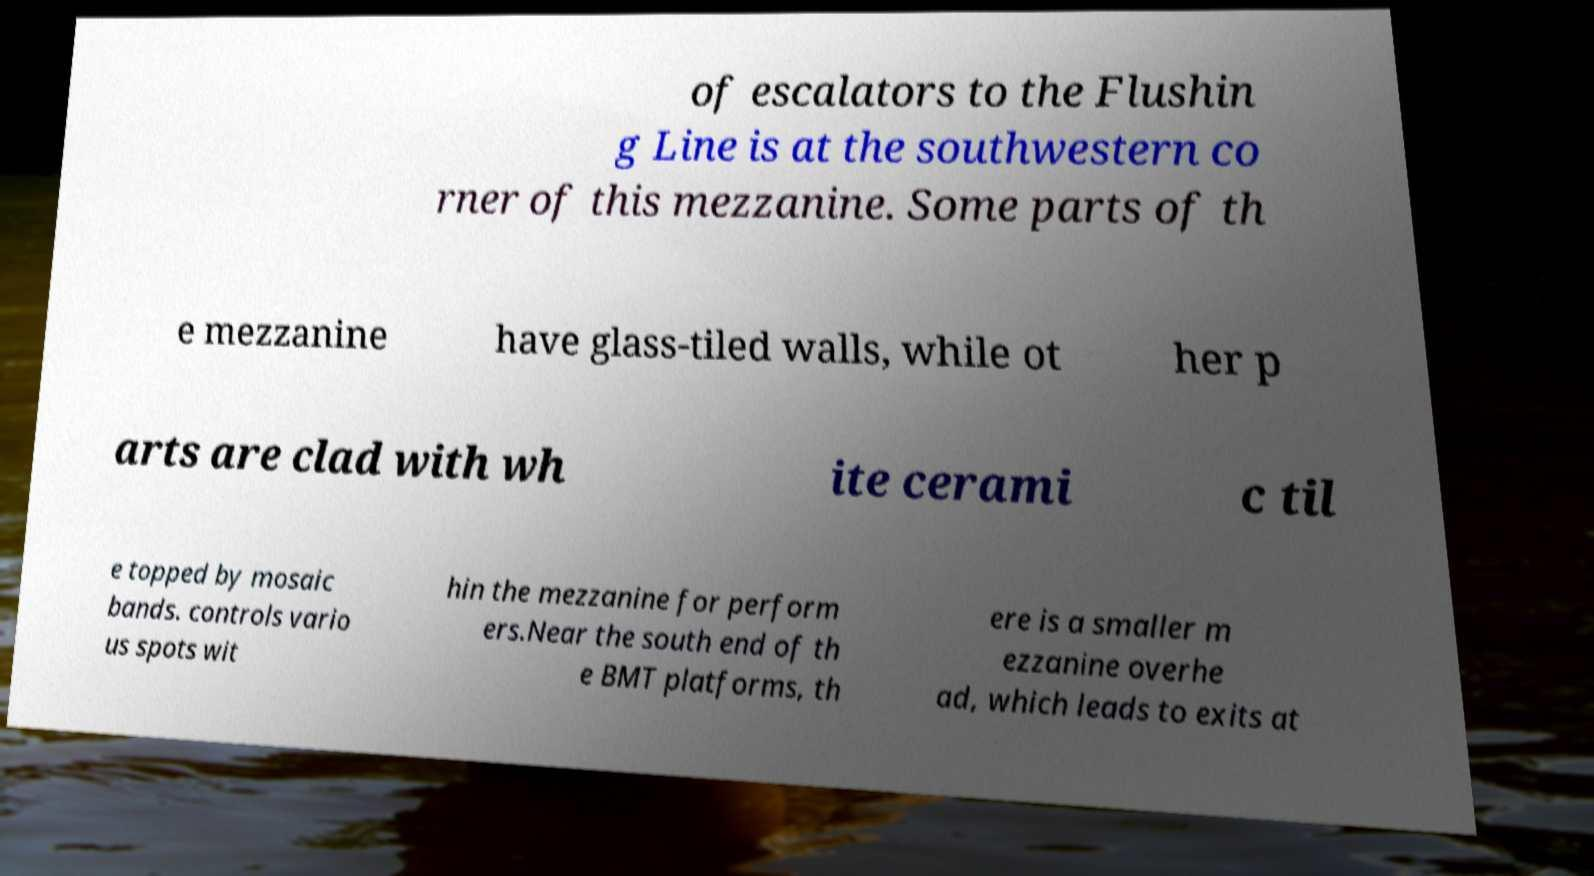Please identify and transcribe the text found in this image. of escalators to the Flushin g Line is at the southwestern co rner of this mezzanine. Some parts of th e mezzanine have glass-tiled walls, while ot her p arts are clad with wh ite cerami c til e topped by mosaic bands. controls vario us spots wit hin the mezzanine for perform ers.Near the south end of th e BMT platforms, th ere is a smaller m ezzanine overhe ad, which leads to exits at 